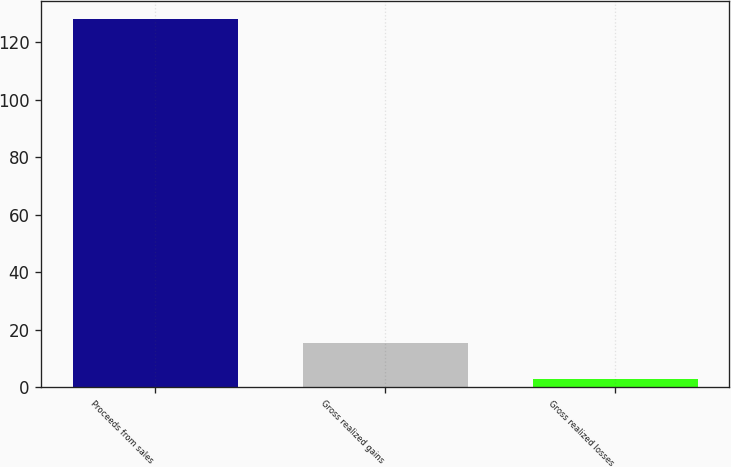Convert chart. <chart><loc_0><loc_0><loc_500><loc_500><bar_chart><fcel>Proceeds from sales<fcel>Gross realized gains<fcel>Gross realized losses<nl><fcel>128<fcel>15.5<fcel>3<nl></chart> 